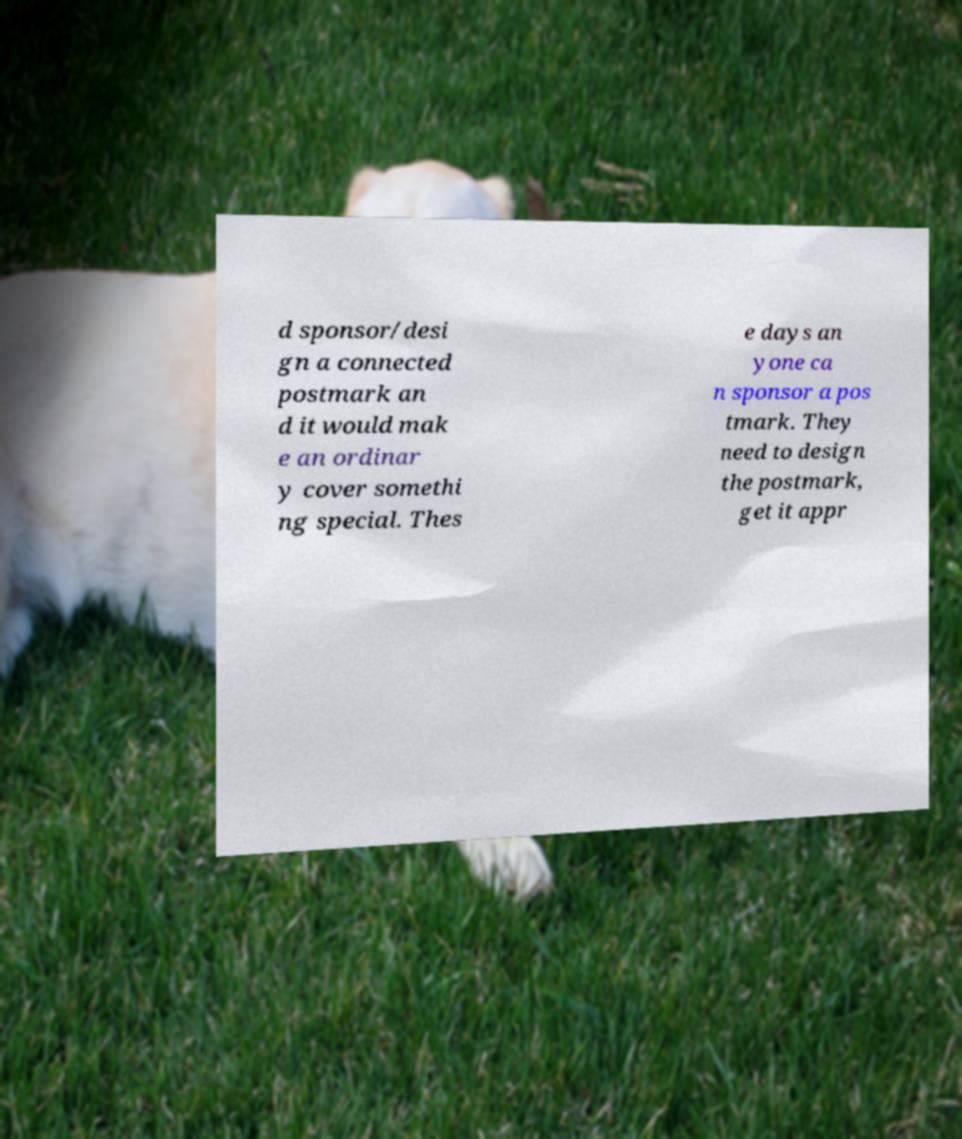Can you accurately transcribe the text from the provided image for me? d sponsor/desi gn a connected postmark an d it would mak e an ordinar y cover somethi ng special. Thes e days an yone ca n sponsor a pos tmark. They need to design the postmark, get it appr 